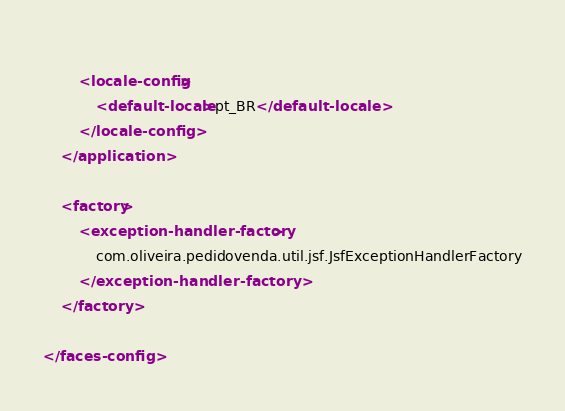Convert code to text. <code><loc_0><loc_0><loc_500><loc_500><_XML_>	
		<locale-config>
			<default-locale>pt_BR</default-locale>
		</locale-config>
	</application>

	<factory>
		<exception-handler-factory>
			com.oliveira.pedidovenda.util.jsf.JsfExceptionHandlerFactory
		</exception-handler-factory>
	</factory>

</faces-config>
</code> 